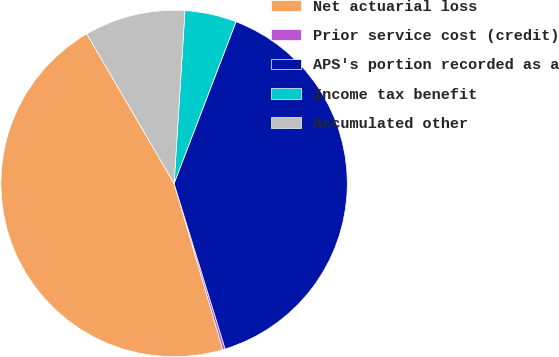Convert chart. <chart><loc_0><loc_0><loc_500><loc_500><pie_chart><fcel>Net actuarial loss<fcel>Prior service cost (credit)<fcel>APS's portion recorded as a<fcel>Income tax benefit<fcel>Accumulated other<nl><fcel>46.13%<fcel>0.23%<fcel>39.42%<fcel>4.82%<fcel>9.41%<nl></chart> 